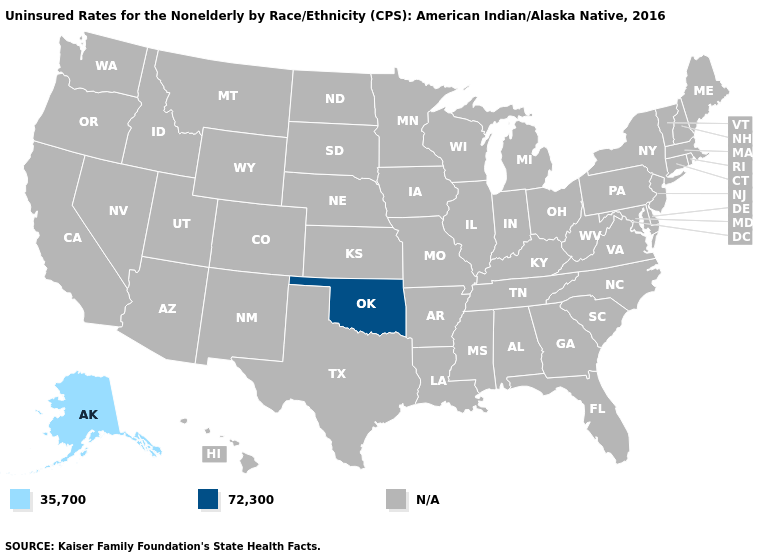Name the states that have a value in the range 35,700?
Quick response, please. Alaska. Which states have the lowest value in the USA?
Write a very short answer. Alaska. What is the value of Georgia?
Concise answer only. N/A. What is the lowest value in the West?
Concise answer only. 35,700. Name the states that have a value in the range N/A?
Write a very short answer. Alabama, Arizona, Arkansas, California, Colorado, Connecticut, Delaware, Florida, Georgia, Hawaii, Idaho, Illinois, Indiana, Iowa, Kansas, Kentucky, Louisiana, Maine, Maryland, Massachusetts, Michigan, Minnesota, Mississippi, Missouri, Montana, Nebraska, Nevada, New Hampshire, New Jersey, New Mexico, New York, North Carolina, North Dakota, Ohio, Oregon, Pennsylvania, Rhode Island, South Carolina, South Dakota, Tennessee, Texas, Utah, Vermont, Virginia, Washington, West Virginia, Wisconsin, Wyoming. What is the value of New Mexico?
Quick response, please. N/A. What is the value of North Carolina?
Answer briefly. N/A. Name the states that have a value in the range 35,700?
Concise answer only. Alaska. Which states have the lowest value in the USA?
Answer briefly. Alaska. 